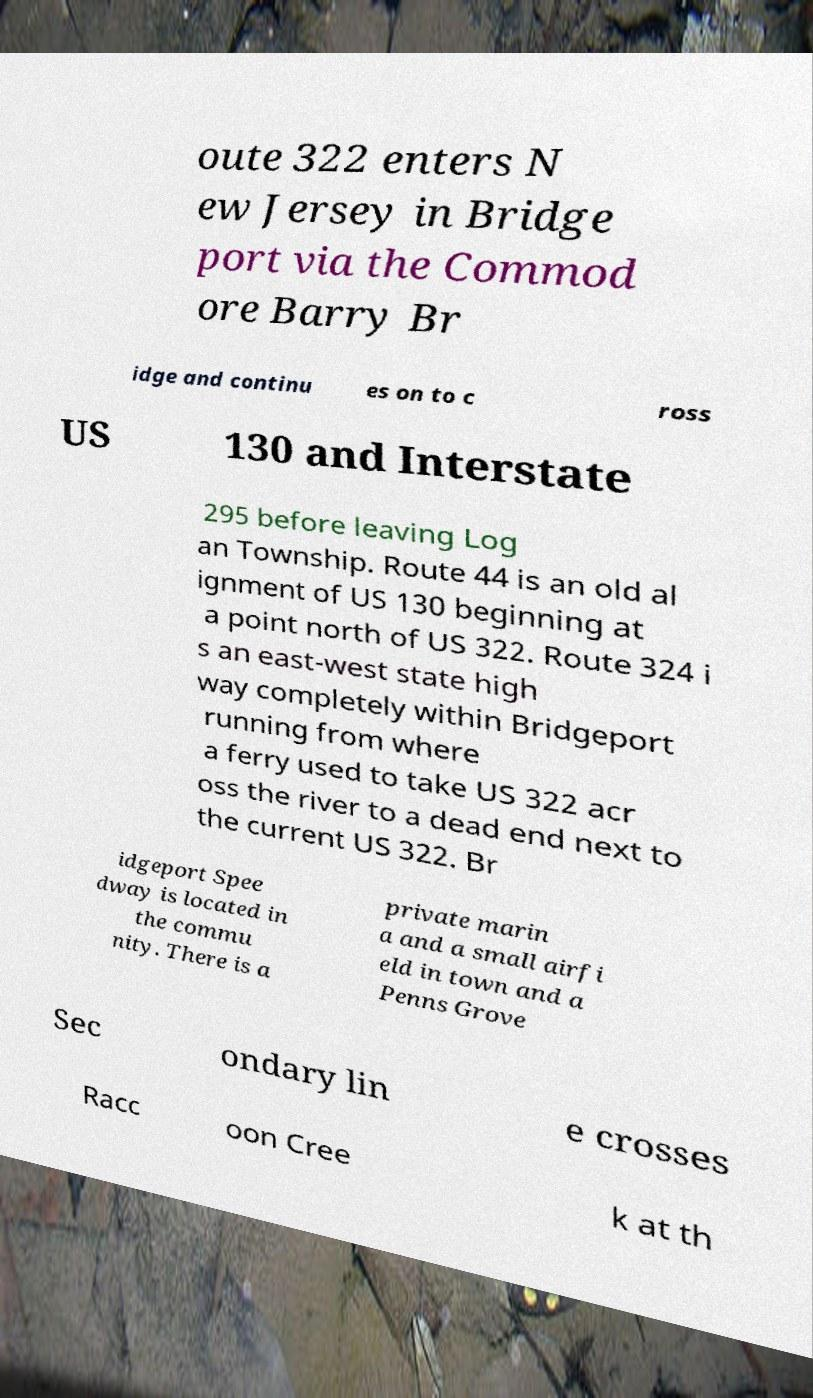Could you assist in decoding the text presented in this image and type it out clearly? oute 322 enters N ew Jersey in Bridge port via the Commod ore Barry Br idge and continu es on to c ross US 130 and Interstate 295 before leaving Log an Township. Route 44 is an old al ignment of US 130 beginning at a point north of US 322. Route 324 i s an east-west state high way completely within Bridgeport running from where a ferry used to take US 322 acr oss the river to a dead end next to the current US 322. Br idgeport Spee dway is located in the commu nity. There is a private marin a and a small airfi eld in town and a Penns Grove Sec ondary lin e crosses Racc oon Cree k at th 